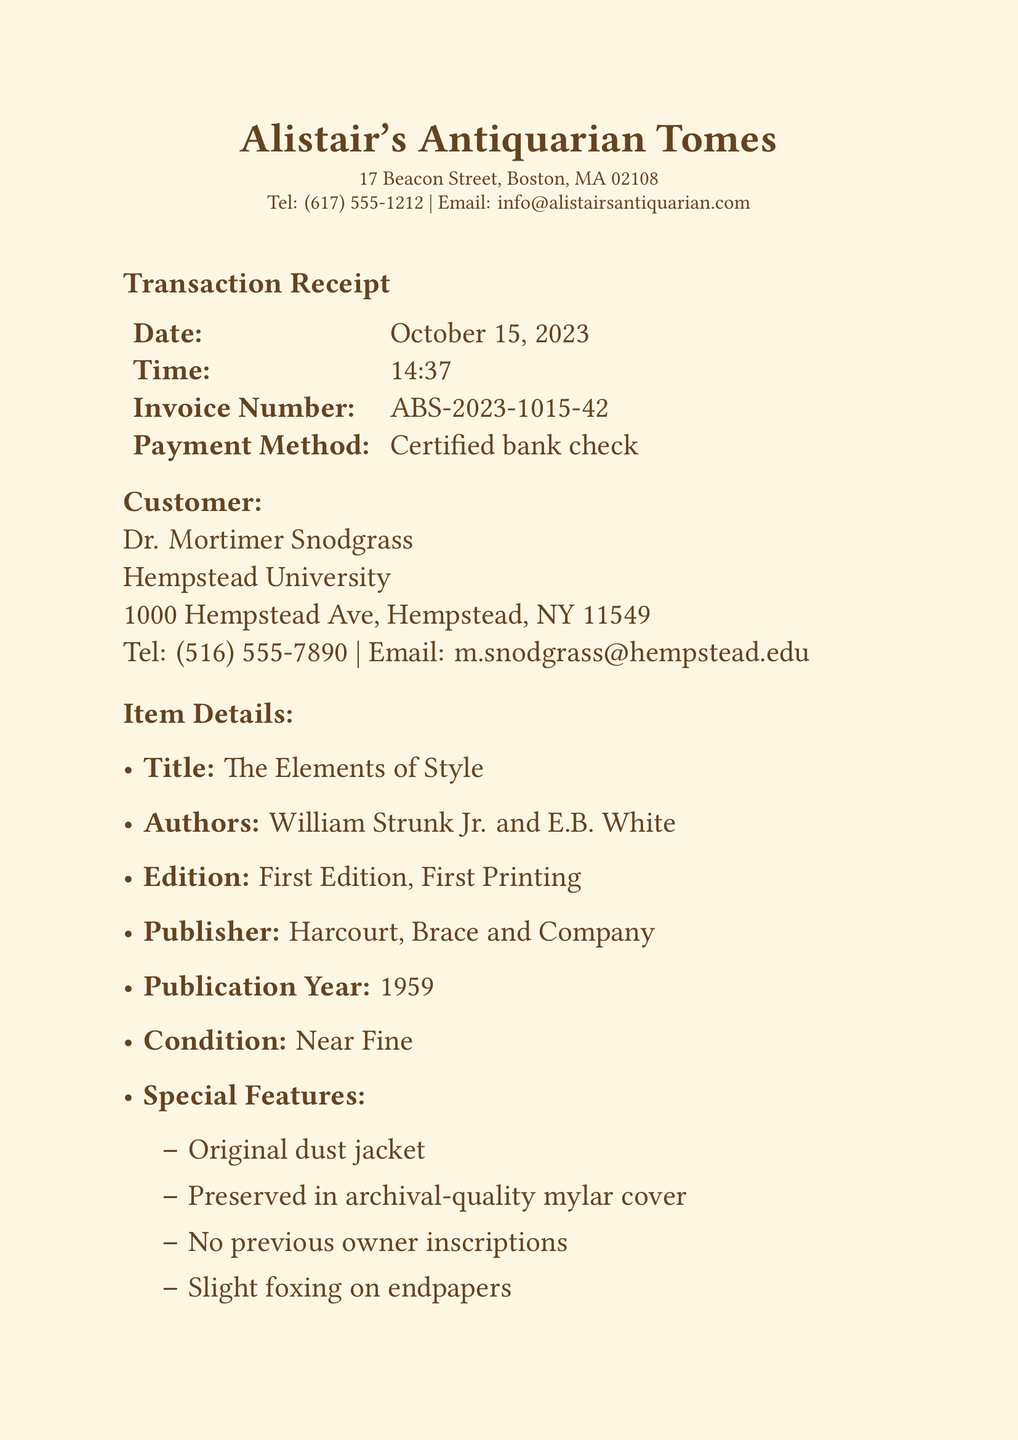What is the date of the transaction? The date of the transaction is stated at the top of the document.
Answer: October 15, 2023 Who purchased the book? The document lists the customer's name in the customer details section.
Answer: Dr. Mortimer Snodgrass What is the list price of the book? The list price is specifically mentioned in the pricing section of the document.
Answer: $4,500.00 What type of payment was used for the transaction? The payment method is specified clearly in the transaction details.
Answer: Certified bank check What is included with the purchase? This information is provided in the additional notes section of the document.
Answer: Certificate of authenticity What is the condition of the book? The condition is described in the item details section.
Answer: Near Fine What is the total price after the academic discount? The total price is noted in the pricing section after calculating the discount.
Answer: $4,200.00 What shipping method is used for the delivery? The shipping method is detailed in the additional notes section.
Answer: FedEx overnight What unique handling item is provided for the book? The unique item for handling the book is mentioned in the additional notes.
Answer: White cotton gloves 